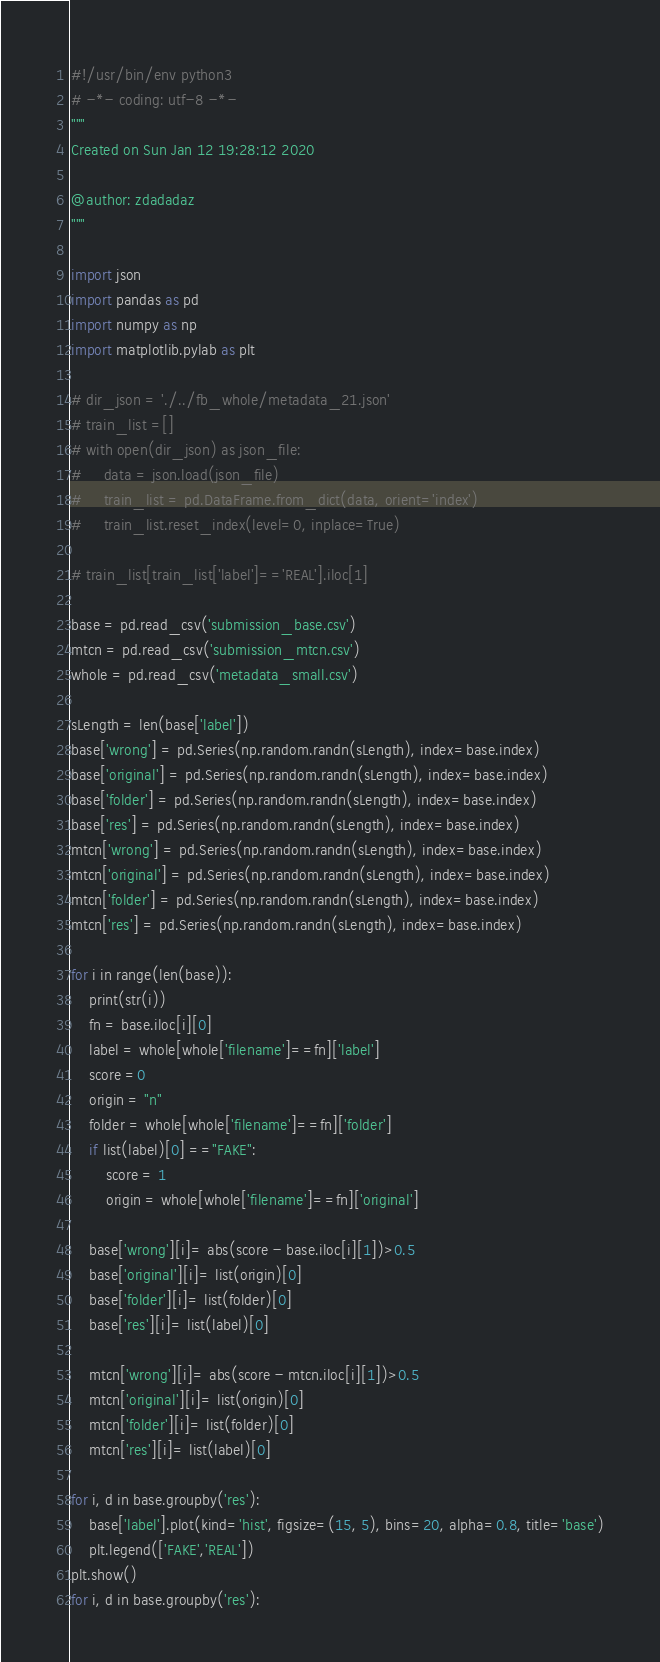Convert code to text. <code><loc_0><loc_0><loc_500><loc_500><_Python_>#!/usr/bin/env python3
# -*- coding: utf-8 -*-
"""
Created on Sun Jan 12 19:28:12 2020

@author: zdadadaz
"""

import json
import pandas as pd
import numpy as np
import matplotlib.pylab as plt

# dir_json = './../fb_whole/metadata_21.json'
# train_list =[]
# with open(dir_json) as json_file:
#     data = json.load(json_file)
#     train_list = pd.DataFrame.from_dict(data, orient='index')
#     train_list.reset_index(level=0, inplace=True)
    
# train_list[train_list['label']=='REAL'].iloc[1]

base = pd.read_csv('submission_base.csv')
mtcn = pd.read_csv('submission_mtcn.csv')
whole = pd.read_csv('metadata_small.csv')

sLength = len(base['label'])
base['wrong'] = pd.Series(np.random.randn(sLength), index=base.index)
base['original'] = pd.Series(np.random.randn(sLength), index=base.index)
base['folder'] = pd.Series(np.random.randn(sLength), index=base.index)
base['res'] = pd.Series(np.random.randn(sLength), index=base.index)
mtcn['wrong'] = pd.Series(np.random.randn(sLength), index=base.index)
mtcn['original'] = pd.Series(np.random.randn(sLength), index=base.index)
mtcn['folder'] = pd.Series(np.random.randn(sLength), index=base.index)
mtcn['res'] = pd.Series(np.random.randn(sLength), index=base.index)

for i in range(len(base)):
    print(str(i))
    fn = base.iloc[i][0]
    label = whole[whole['filename']==fn]['label']
    score =0
    origin = "n"
    folder = whole[whole['filename']==fn]['folder']
    if list(label)[0] =="FAKE":
        score = 1
        origin = whole[whole['filename']==fn]['original']
    
    base['wrong'][i]= abs(score - base.iloc[i][1])>0.5
    base['original'][i]= list(origin)[0]
    base['folder'][i]= list(folder)[0]
    base['res'][i]= list(label)[0]
    
    mtcn['wrong'][i]= abs(score - mtcn.iloc[i][1])>0.5
    mtcn['original'][i]= list(origin)[0]
    mtcn['folder'][i]= list(folder)[0]
    mtcn['res'][i]= list(label)[0]
    
for i, d in base.groupby('res'):
    base['label'].plot(kind='hist', figsize=(15, 5), bins=20, alpha=0.8, title='base')
    plt.legend(['FAKE','REAL'])
plt.show()
for i, d in base.groupby('res'):</code> 